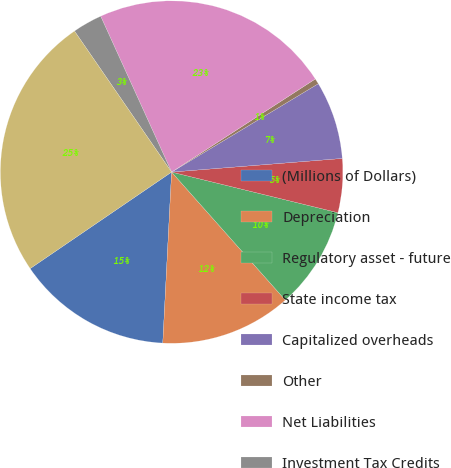Convert chart to OTSL. <chart><loc_0><loc_0><loc_500><loc_500><pie_chart><fcel>(Millions of Dollars)<fcel>Depreciation<fcel>Regulatory asset - future<fcel>State income tax<fcel>Capitalized overheads<fcel>Other<fcel>Net Liabilities<fcel>Investment Tax Credits<fcel>Deferred Income Taxes and<nl><fcel>14.65%<fcel>12.38%<fcel>9.63%<fcel>5.08%<fcel>7.36%<fcel>0.52%<fcel>22.65%<fcel>2.8%<fcel>24.93%<nl></chart> 